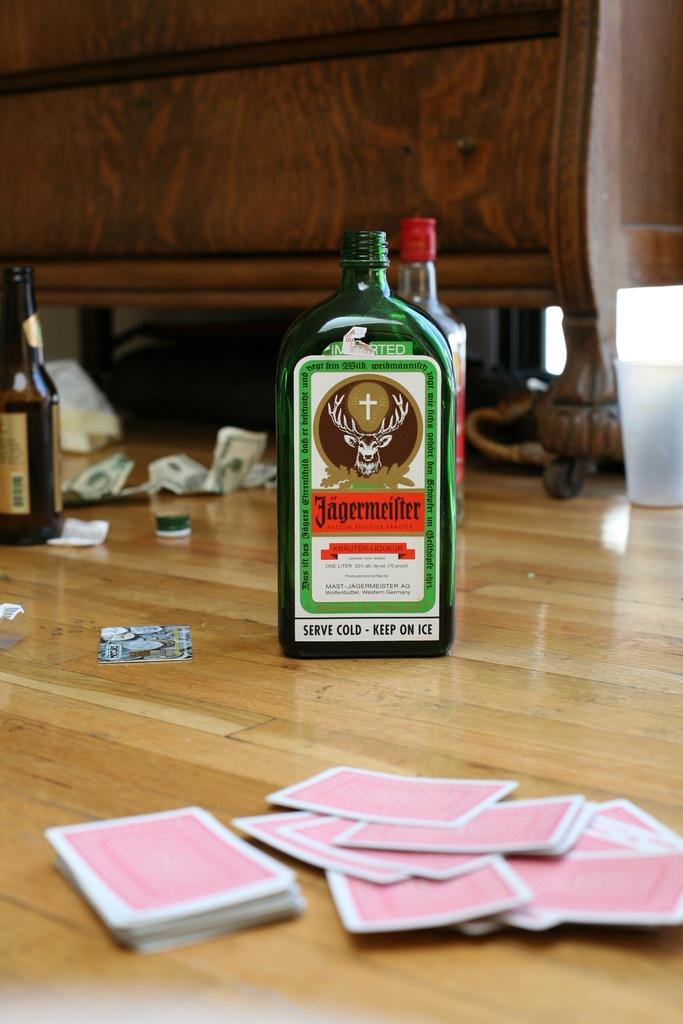What is the name on the green bottle?
Provide a short and direct response. Jagermeister. How should the drink in the green bottle be served?
Your answer should be compact. Cold. 